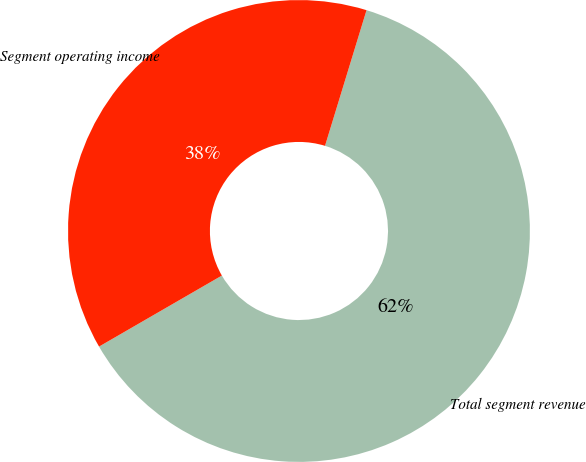<chart> <loc_0><loc_0><loc_500><loc_500><pie_chart><fcel>Total segment revenue<fcel>Segment operating income<nl><fcel>61.93%<fcel>38.07%<nl></chart> 